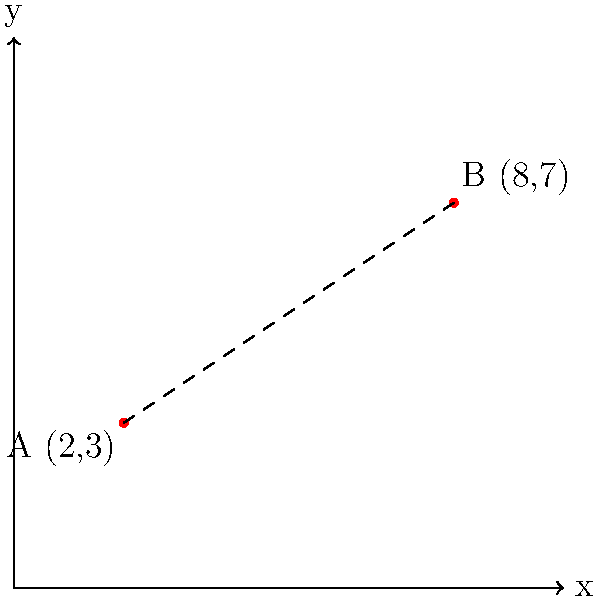As a pharmacist managing medications for clinical trial participants, you need to calculate the distance between two pharmacies that store trial medications. Pharmacy A is located at coordinates (2,3) and Pharmacy B is at (8,7) on a city grid where each unit represents 1 km. Using the distance formula, calculate the straight-line distance between these two pharmacies to the nearest tenth of a kilometer. To solve this problem, we'll use the distance formula derived from the Pythagorean theorem:

$$ d = \sqrt{(x_2 - x_1)^2 + (y_2 - y_1)^2} $$

Where $(x_1, y_1)$ are the coordinates of the first point and $(x_2, y_2)$ are the coordinates of the second point.

Step 1: Identify the coordinates
- Pharmacy A: $(x_1, y_1) = (2, 3)$
- Pharmacy B: $(x_2, y_2) = (8, 7)$

Step 2: Plug the coordinates into the distance formula
$$ d = \sqrt{(8 - 2)^2 + (7 - 3)^2} $$

Step 3: Simplify the expressions inside the parentheses
$$ d = \sqrt{6^2 + 4^2} $$

Step 4: Calculate the squares
$$ d = \sqrt{36 + 16} $$

Step 5: Add the numbers under the square root
$$ d = \sqrt{52} $$

Step 6: Calculate the square root and round to the nearest tenth
$$ d \approx 7.2 $$

Therefore, the distance between Pharmacy A and Pharmacy B is approximately 7.2 km.
Answer: 7.2 km 